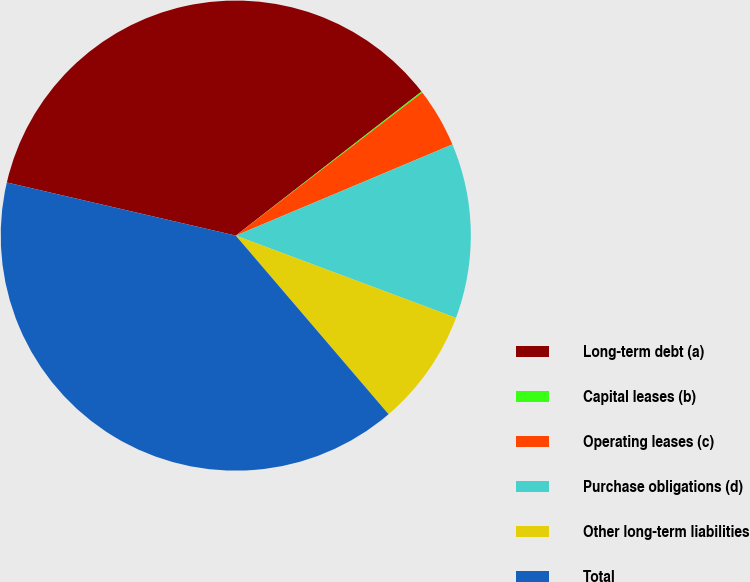<chart> <loc_0><loc_0><loc_500><loc_500><pie_chart><fcel>Long-term debt (a)<fcel>Capital leases (b)<fcel>Operating leases (c)<fcel>Purchase obligations (d)<fcel>Other long-term liabilities<fcel>Total<nl><fcel>35.87%<fcel>0.09%<fcel>4.07%<fcel>12.03%<fcel>8.05%<fcel>39.89%<nl></chart> 